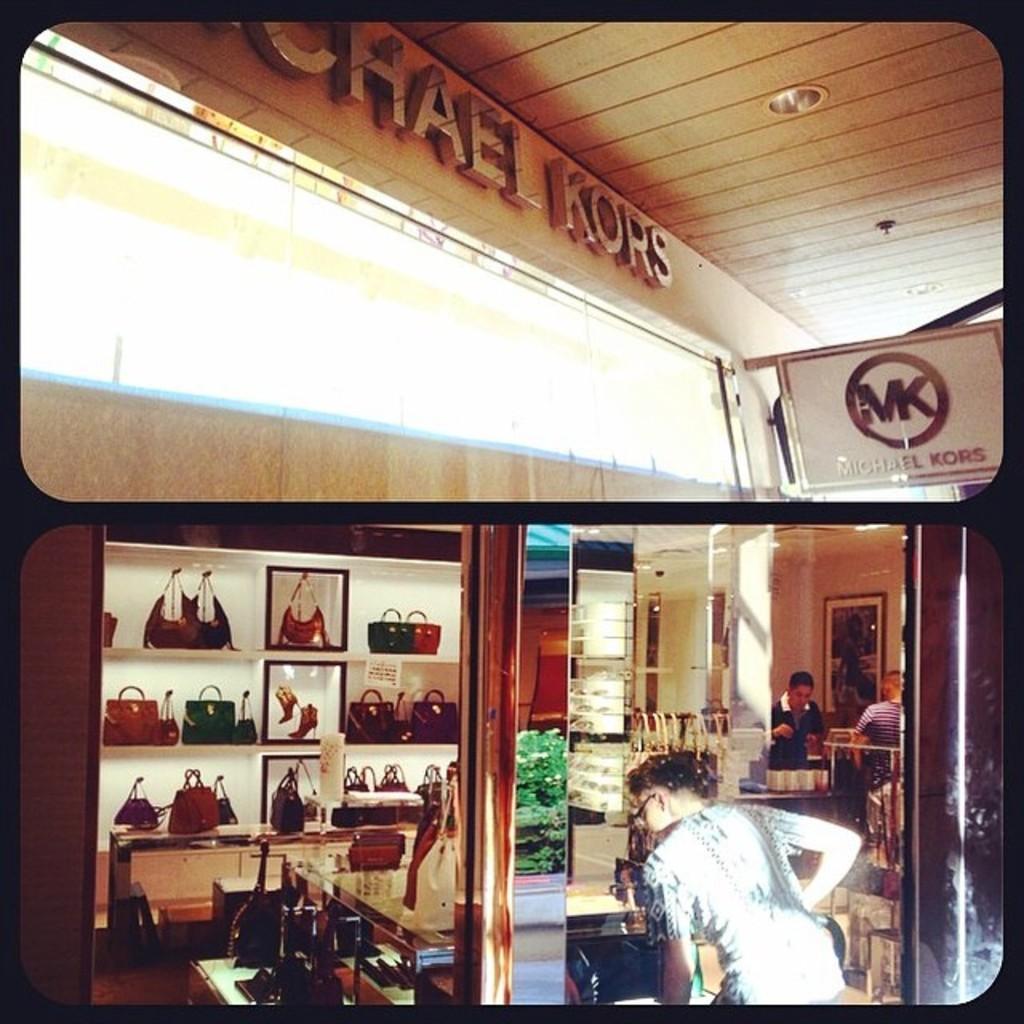Could you give a brief overview of what you see in this image? In the image there is a woman standing on the right side in the back, there are shelves with handbags in it, it seems to be in a bag store. 